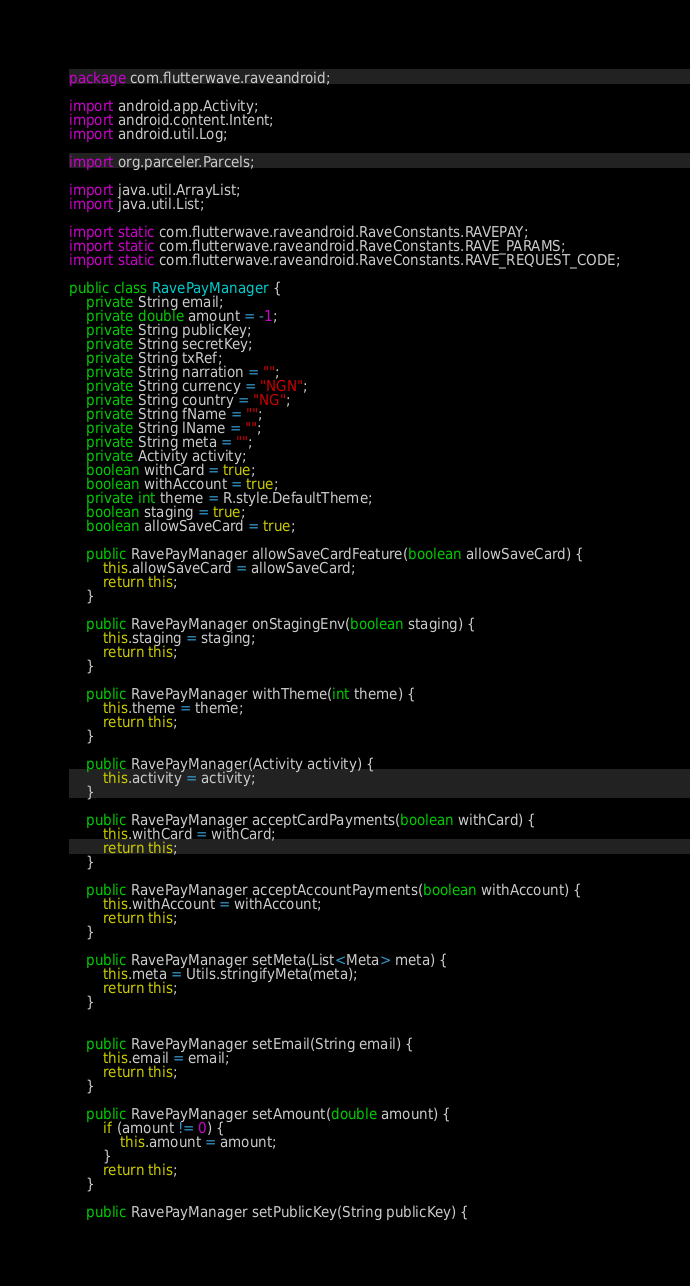<code> <loc_0><loc_0><loc_500><loc_500><_Java_>package com.flutterwave.raveandroid;

import android.app.Activity;
import android.content.Intent;
import android.util.Log;

import org.parceler.Parcels;

import java.util.ArrayList;
import java.util.List;

import static com.flutterwave.raveandroid.RaveConstants.RAVEPAY;
import static com.flutterwave.raveandroid.RaveConstants.RAVE_PARAMS;
import static com.flutterwave.raveandroid.RaveConstants.RAVE_REQUEST_CODE;

public class RavePayManager {
    private String email;
    private double amount = -1;
    private String publicKey;
    private String secretKey;
    private String txRef;
    private String narration = "";
    private String currency = "NGN";
    private String country = "NG";
    private String fName = "";
    private String lName = "";
    private String meta = "";
    private Activity activity;
    boolean withCard = true;
    boolean withAccount = true;
    private int theme = R.style.DefaultTheme;
    boolean staging = true;
    boolean allowSaveCard = true;

    public RavePayManager allowSaveCardFeature(boolean allowSaveCard) {
        this.allowSaveCard = allowSaveCard;
        return this;
    }

    public RavePayManager onStagingEnv(boolean staging) {
        this.staging = staging;
        return this;
    }

    public RavePayManager withTheme(int theme) {
        this.theme = theme;
        return this;
    }

    public RavePayManager(Activity activity) {
        this.activity = activity;
    }

    public RavePayManager acceptCardPayments(boolean withCard) {
        this.withCard = withCard;
        return this;
    }

    public RavePayManager acceptAccountPayments(boolean withAccount) {
        this.withAccount = withAccount;
        return this;
    }

    public RavePayManager setMeta(List<Meta> meta) {
        this.meta = Utils.stringifyMeta(meta);
        return this;
    }


    public RavePayManager setEmail(String email) {
        this.email = email;
        return this;
    }

    public RavePayManager setAmount(double amount) {
        if (amount != 0) {
            this.amount = amount;
        }
        return this;
    }

    public RavePayManager setPublicKey(String publicKey) {</code> 